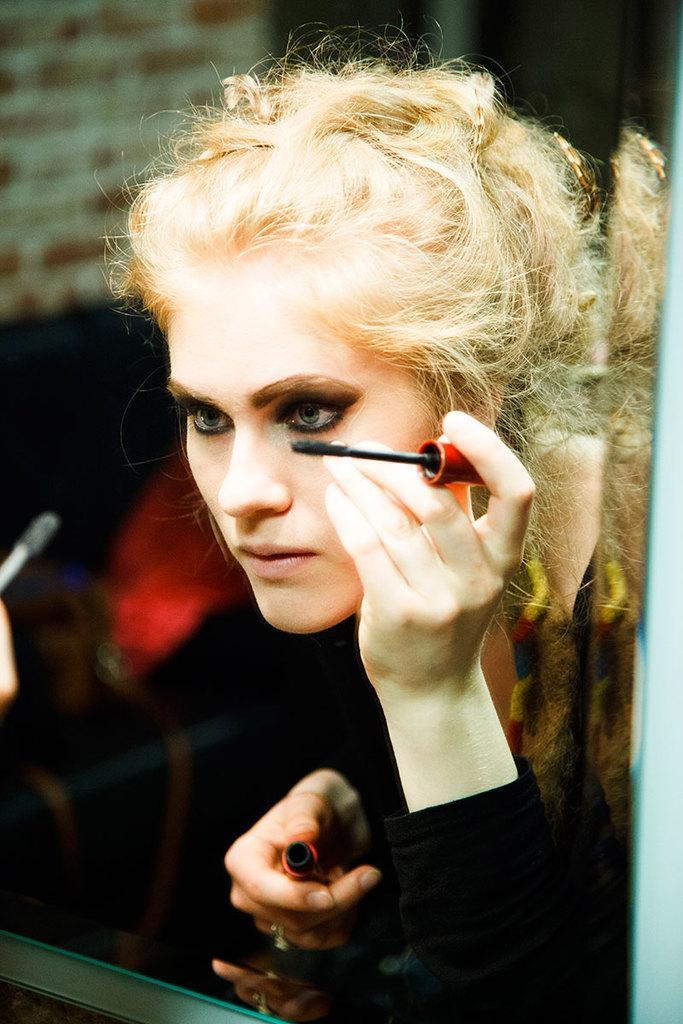Can you describe this image briefly? In this image, We can see a woman standing in front of mirror and holding cosmetic. 